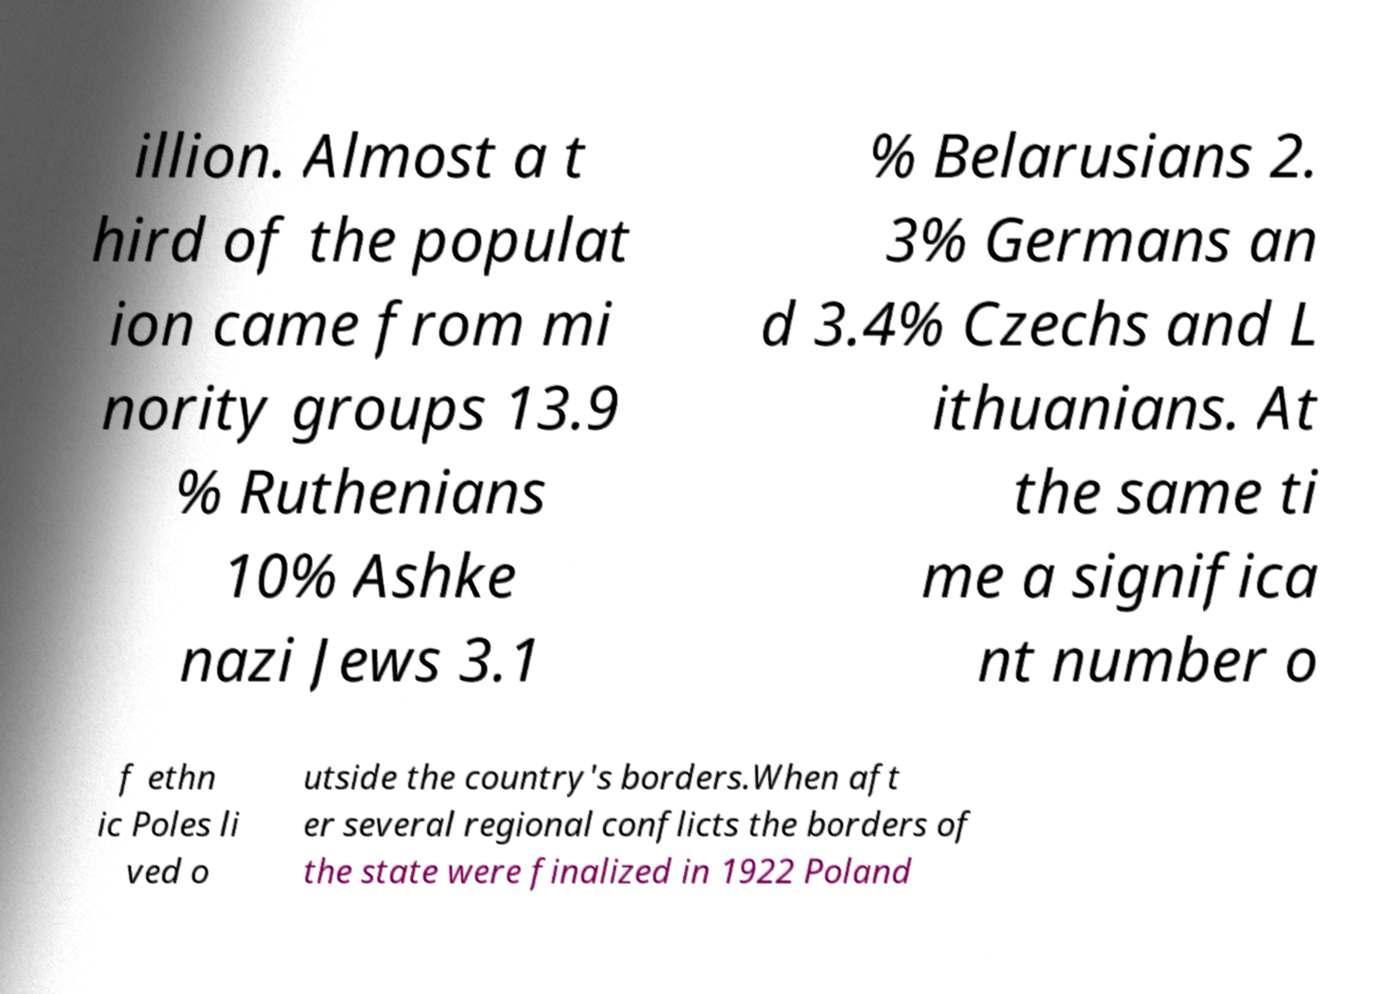Please read and relay the text visible in this image. What does it say? illion. Almost a t hird of the populat ion came from mi nority groups 13.9 % Ruthenians 10% Ashke nazi Jews 3.1 % Belarusians 2. 3% Germans an d 3.4% Czechs and L ithuanians. At the same ti me a significa nt number o f ethn ic Poles li ved o utside the country's borders.When aft er several regional conflicts the borders of the state were finalized in 1922 Poland 